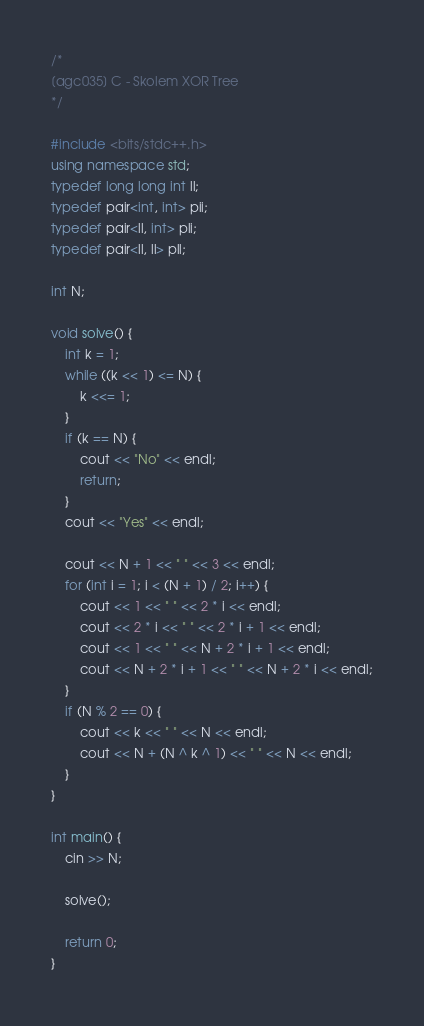<code> <loc_0><loc_0><loc_500><loc_500><_C++_>/*
[agc035] C - Skolem XOR Tree
*/

#include <bits/stdc++.h>
using namespace std;
typedef long long int ll;
typedef pair<int, int> pii;
typedef pair<ll, int> pli;
typedef pair<ll, ll> pll;

int N;

void solve() {
    int k = 1;
    while ((k << 1) <= N) {
        k <<= 1;
    }
    if (k == N) {
        cout << "No" << endl;
        return;
    }
    cout << "Yes" << endl;

    cout << N + 1 << " " << 3 << endl;
    for (int i = 1; i < (N + 1) / 2; i++) {
        cout << 1 << " " << 2 * i << endl;
        cout << 2 * i << " " << 2 * i + 1 << endl;
        cout << 1 << " " << N + 2 * i + 1 << endl;
        cout << N + 2 * i + 1 << " " << N + 2 * i << endl;
    }
    if (N % 2 == 0) {
        cout << k << " " << N << endl;
        cout << N + (N ^ k ^ 1) << " " << N << endl;
    }
}

int main() {
    cin >> N;

    solve();

    return 0;
}
</code> 